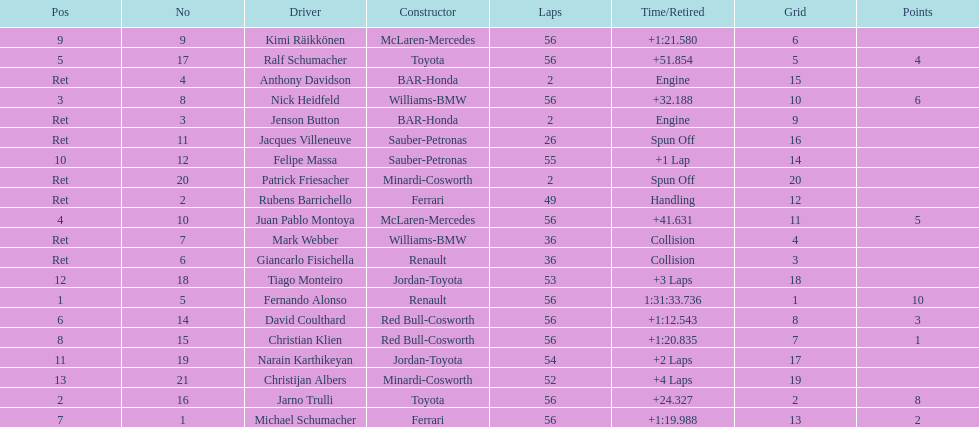Who finished before nick heidfeld? Jarno Trulli. 